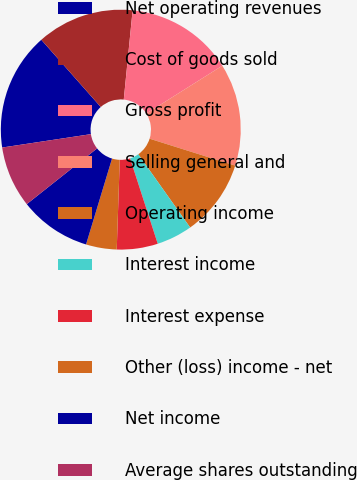<chart> <loc_0><loc_0><loc_500><loc_500><pie_chart><fcel>Net operating revenues<fcel>Cost of goods sold<fcel>Gross profit<fcel>Selling general and<fcel>Operating income<fcel>Interest income<fcel>Interest expense<fcel>Other (loss) income - net<fcel>Net income<fcel>Average shares outstanding<nl><fcel>15.86%<fcel>13.1%<fcel>14.48%<fcel>13.79%<fcel>10.34%<fcel>4.83%<fcel>5.52%<fcel>4.14%<fcel>9.66%<fcel>8.28%<nl></chart> 